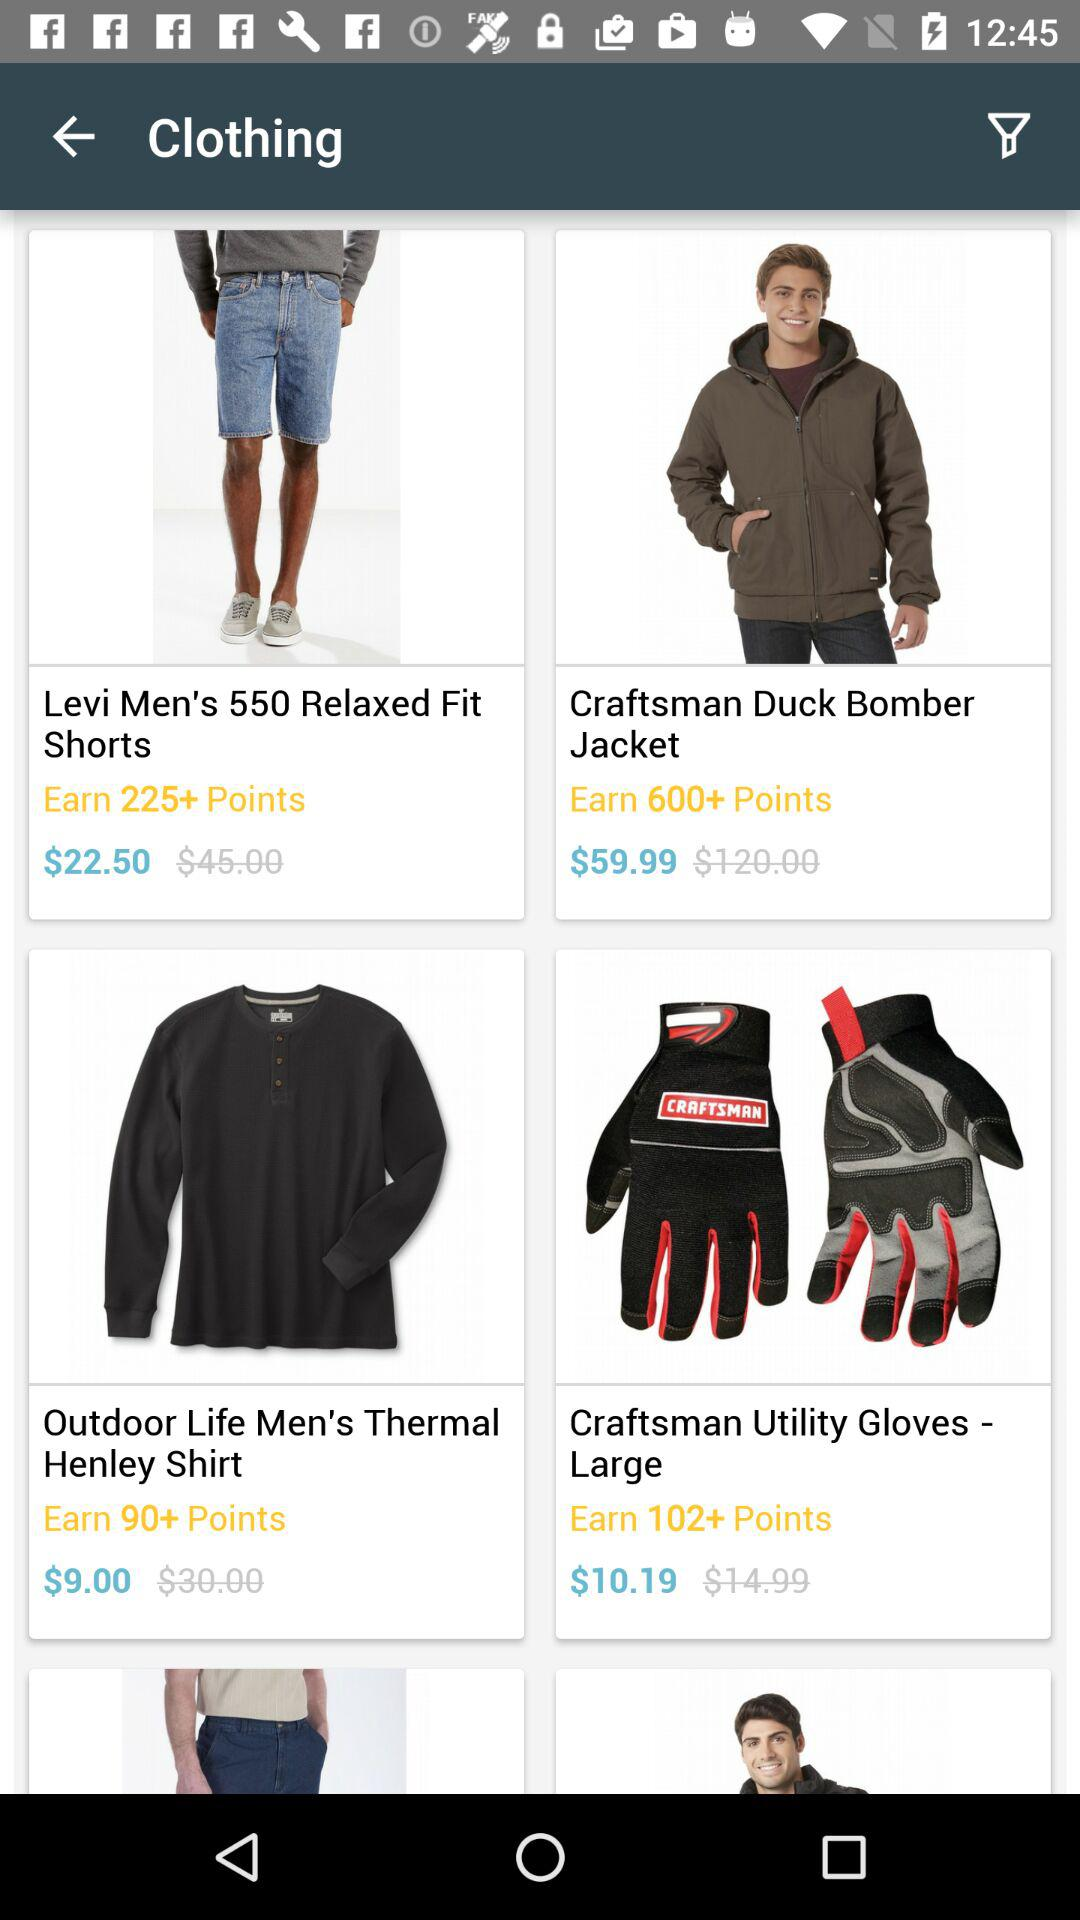What is the price of "Levi Men's 550 Relaxed Fit Shorts"? The price is $22.50. 